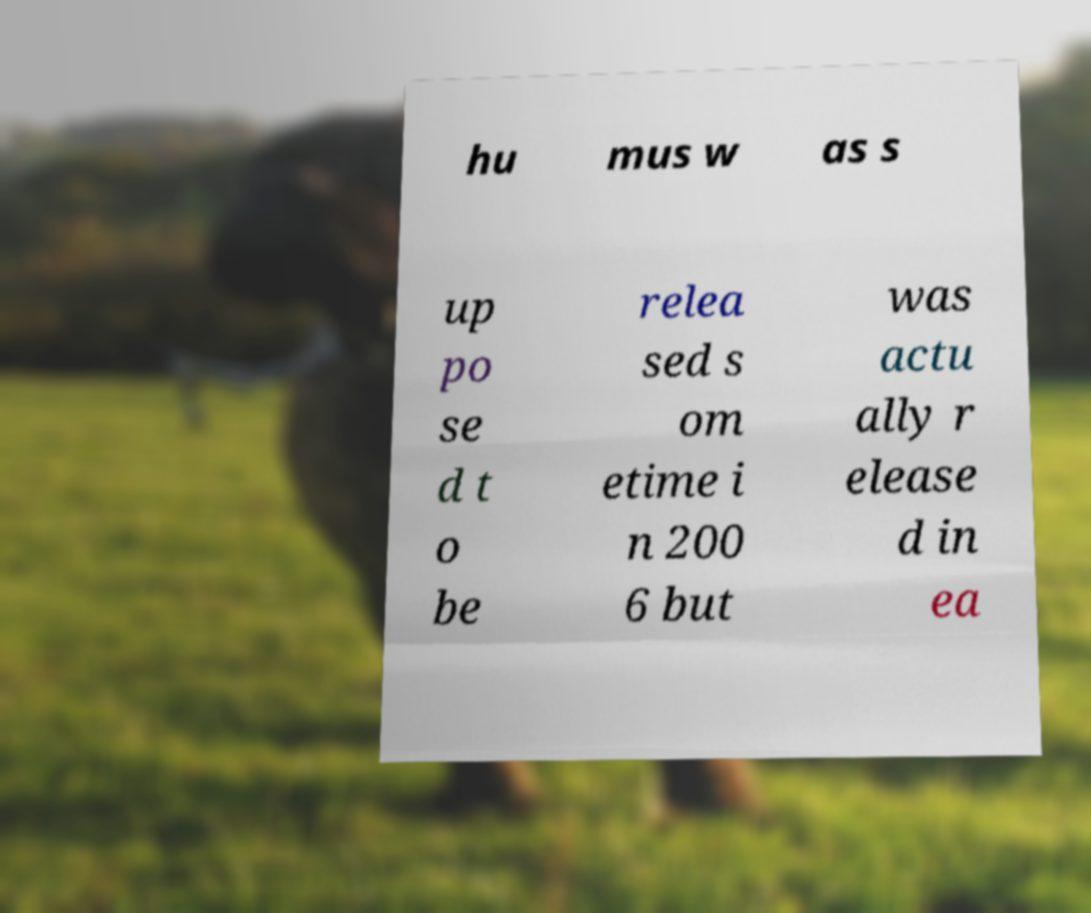Please read and relay the text visible in this image. What does it say? hu mus w as s up po se d t o be relea sed s om etime i n 200 6 but was actu ally r elease d in ea 